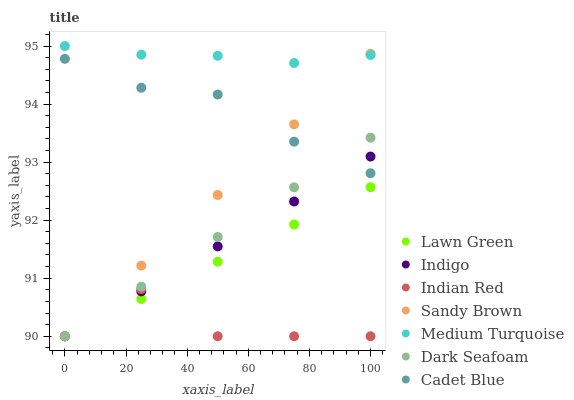Does Indian Red have the minimum area under the curve?
Answer yes or no. Yes. Does Medium Turquoise have the maximum area under the curve?
Answer yes or no. Yes. Does Cadet Blue have the minimum area under the curve?
Answer yes or no. No. Does Cadet Blue have the maximum area under the curve?
Answer yes or no. No. Is Indigo the smoothest?
Answer yes or no. Yes. Is Indian Red the roughest?
Answer yes or no. Yes. Is Cadet Blue the smoothest?
Answer yes or no. No. Is Cadet Blue the roughest?
Answer yes or no. No. Does Lawn Green have the lowest value?
Answer yes or no. Yes. Does Cadet Blue have the lowest value?
Answer yes or no. No. Does Medium Turquoise have the highest value?
Answer yes or no. Yes. Does Cadet Blue have the highest value?
Answer yes or no. No. Is Lawn Green less than Cadet Blue?
Answer yes or no. Yes. Is Medium Turquoise greater than Lawn Green?
Answer yes or no. Yes. Does Indigo intersect Dark Seafoam?
Answer yes or no. Yes. Is Indigo less than Dark Seafoam?
Answer yes or no. No. Is Indigo greater than Dark Seafoam?
Answer yes or no. No. Does Lawn Green intersect Cadet Blue?
Answer yes or no. No. 